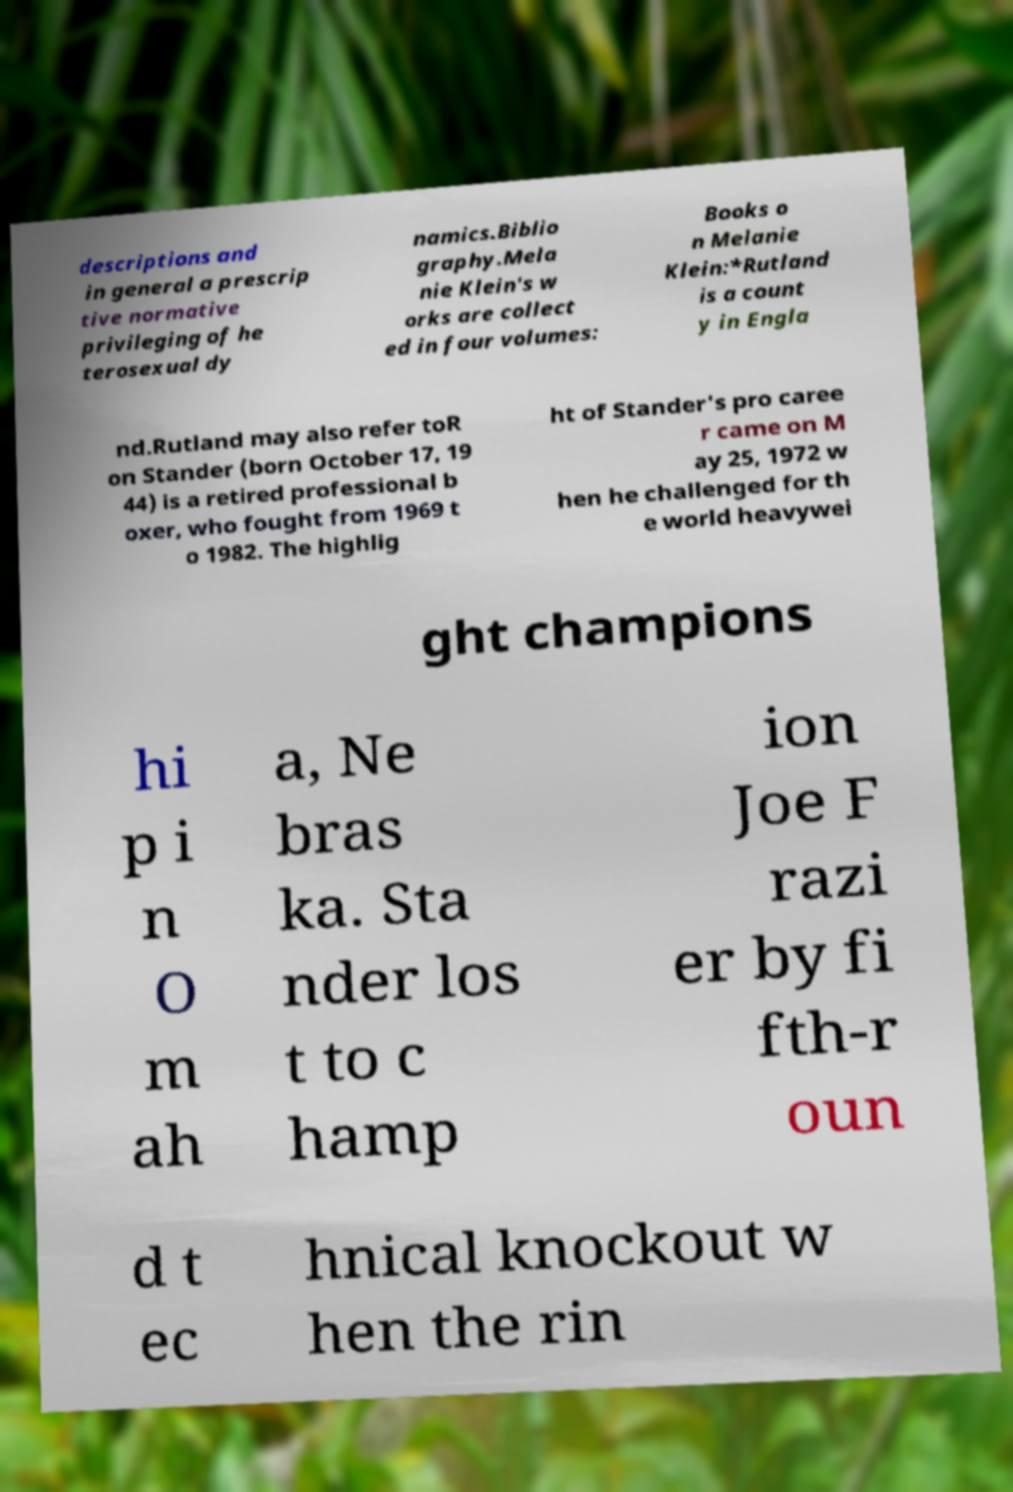Please identify and transcribe the text found in this image. descriptions and in general a prescrip tive normative privileging of he terosexual dy namics.Biblio graphy.Mela nie Klein's w orks are collect ed in four volumes: Books o n Melanie Klein:*Rutland is a count y in Engla nd.Rutland may also refer toR on Stander (born October 17, 19 44) is a retired professional b oxer, who fought from 1969 t o 1982. The highlig ht of Stander's pro caree r came on M ay 25, 1972 w hen he challenged for th e world heavywei ght champions hi p i n O m ah a, Ne bras ka. Sta nder los t to c hamp ion Joe F razi er by fi fth-r oun d t ec hnical knockout w hen the rin 